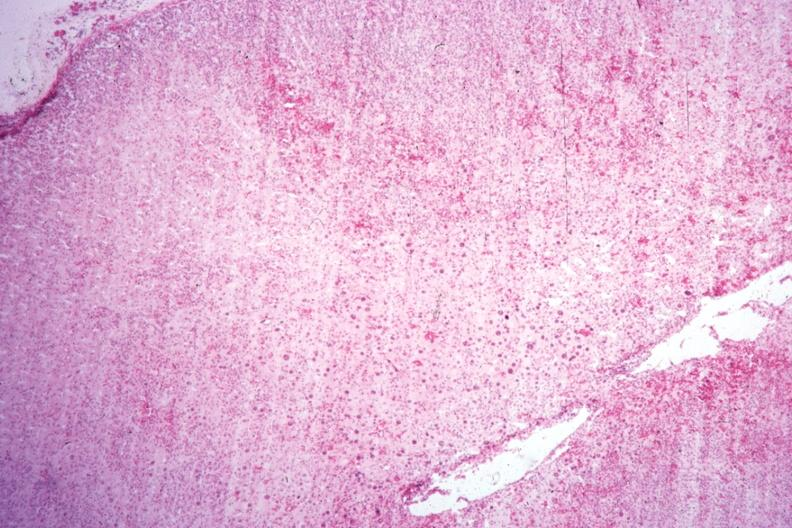s endocrine present?
Answer the question using a single word or phrase. Yes 